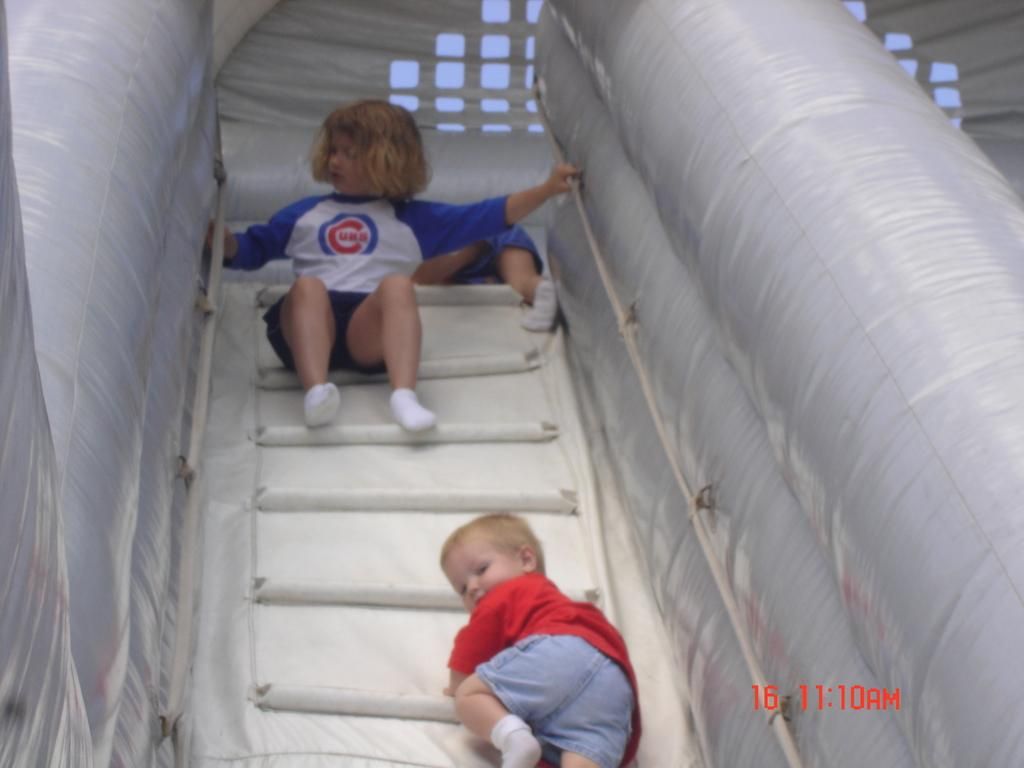What type of object can be seen in the image? There is an inflatable object in the image. Who is present in the image? There are infants in the image. Is there any text visible in the image? Yes, there is some numbers text at the bottom of the image. What type of fork is being used by the dinosaurs in the image? There are no dinosaurs or forks present in the image. 